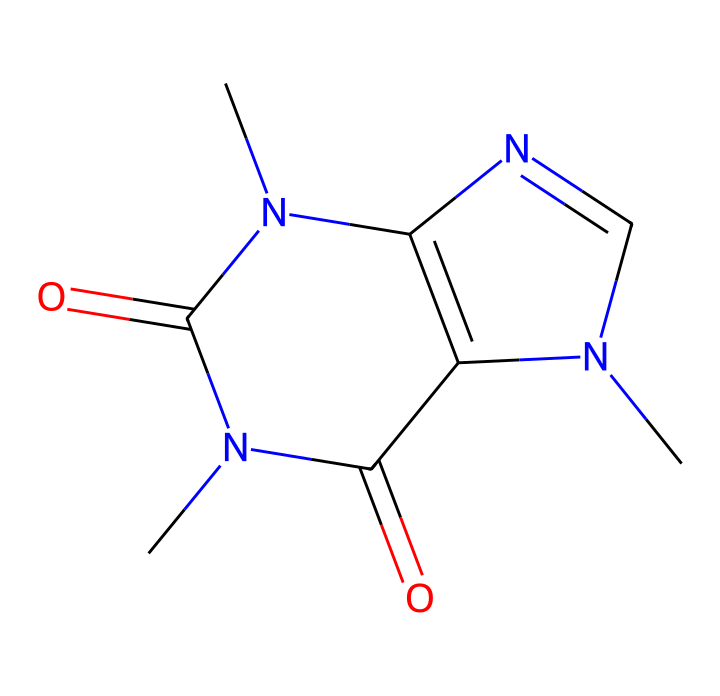How many carbon atoms are in this structure? By analyzing the SMILES, we can count the number of carbon (C) atoms present. In the structure, there are four occurrences of the letter 'C', which confirms four carbon atoms.
Answer: 4 What is the functional group present in this compound? Looking at the structure and the presence of different atoms, particularly the nitrogen atoms (N) and carbonyl (C=O) groups, we can identify that there are amine and amide functional groups present in this molecule.
Answer: amine and amide How many nitrogen atoms are in the caffeine structure? The SMILES shows 'N' appears three times, indicating that there are three nitrogen atoms within the molecule.
Answer: 3 What type of chemical is caffeine categorized as? Examining the structure, we can determine that caffeine is classified as an alkaloid due to the presence of nitrogen atoms and its natural occurrence in plants.
Answer: alkaloid What is the oxidation state of the carbonyl carbon in caffeine? When we examine the carbonyl (C=O) group in the structure, we see that the carbon bonded to oxygen typically has a higher oxidation state, reflecting a +2 oxidation state due to the double bond with oxygen.
Answer: +2 